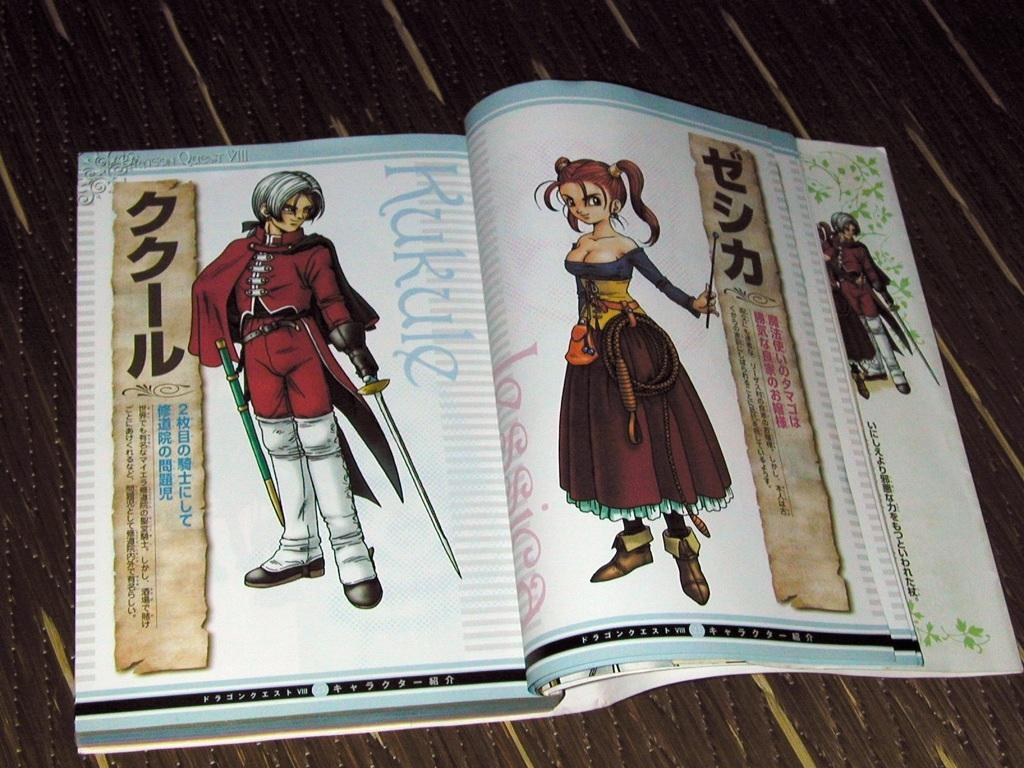What is the main subject in the center of the image? There is an object in the center of the image. What is placed on the object? There is a book on the object. What type of book is it? The book has cartoon characters on it. Are there any words on the book? Yes, the book has some text on it. What type of dinner is being served in the church in the image? There is no dinner or church present in the image; it features an object with a book on it. Can you tell me how many rats are hiding behind the book in the image? There are no rats present in the image. 